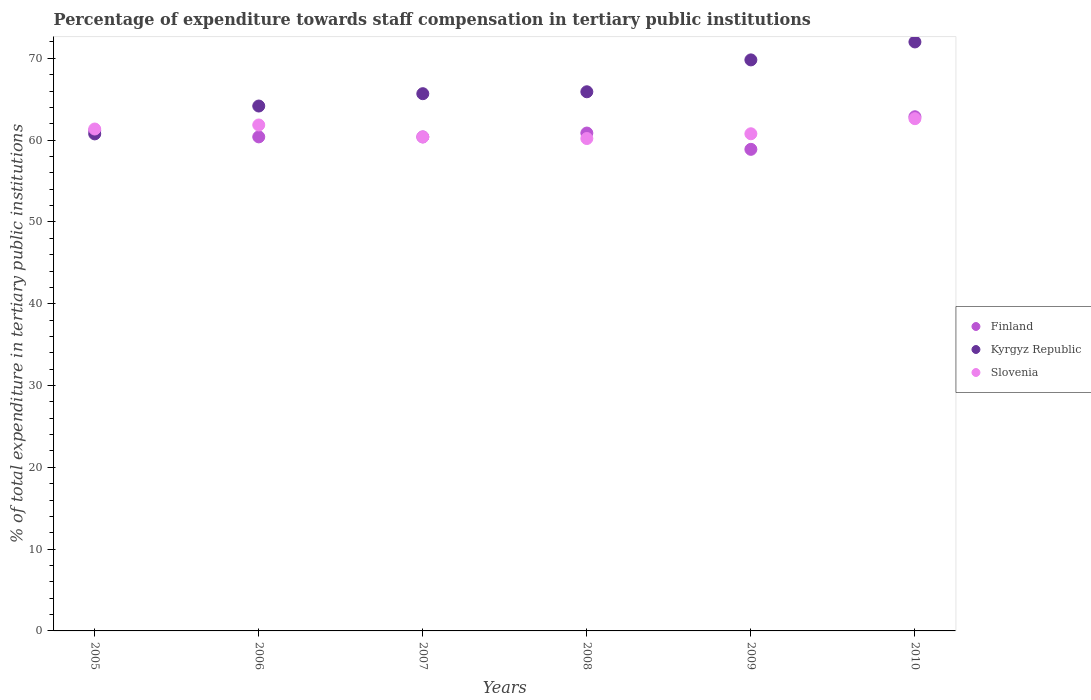What is the percentage of expenditure towards staff compensation in Finland in 2007?
Give a very brief answer. 60.39. Across all years, what is the maximum percentage of expenditure towards staff compensation in Slovenia?
Your answer should be compact. 62.63. Across all years, what is the minimum percentage of expenditure towards staff compensation in Finland?
Keep it short and to the point. 58.88. In which year was the percentage of expenditure towards staff compensation in Finland maximum?
Keep it short and to the point. 2010. In which year was the percentage of expenditure towards staff compensation in Slovenia minimum?
Your answer should be compact. 2008. What is the total percentage of expenditure towards staff compensation in Slovenia in the graph?
Provide a short and direct response. 367.21. What is the difference between the percentage of expenditure towards staff compensation in Kyrgyz Republic in 2006 and that in 2008?
Provide a succinct answer. -1.74. What is the difference between the percentage of expenditure towards staff compensation in Kyrgyz Republic in 2010 and the percentage of expenditure towards staff compensation in Slovenia in 2008?
Provide a short and direct response. 11.81. What is the average percentage of expenditure towards staff compensation in Kyrgyz Republic per year?
Offer a very short reply. 66.39. In the year 2010, what is the difference between the percentage of expenditure towards staff compensation in Kyrgyz Republic and percentage of expenditure towards staff compensation in Slovenia?
Your response must be concise. 9.38. In how many years, is the percentage of expenditure towards staff compensation in Kyrgyz Republic greater than 54 %?
Your answer should be compact. 6. What is the ratio of the percentage of expenditure towards staff compensation in Kyrgyz Republic in 2008 to that in 2009?
Make the answer very short. 0.94. What is the difference between the highest and the second highest percentage of expenditure towards staff compensation in Slovenia?
Your answer should be compact. 0.77. What is the difference between the highest and the lowest percentage of expenditure towards staff compensation in Finland?
Ensure brevity in your answer.  3.98. Is the sum of the percentage of expenditure towards staff compensation in Slovenia in 2005 and 2007 greater than the maximum percentage of expenditure towards staff compensation in Kyrgyz Republic across all years?
Provide a short and direct response. Yes. Is it the case that in every year, the sum of the percentage of expenditure towards staff compensation in Finland and percentage of expenditure towards staff compensation in Kyrgyz Republic  is greater than the percentage of expenditure towards staff compensation in Slovenia?
Provide a short and direct response. Yes. Does the percentage of expenditure towards staff compensation in Finland monotonically increase over the years?
Your answer should be compact. No. How many dotlines are there?
Offer a very short reply. 3. What is the difference between two consecutive major ticks on the Y-axis?
Keep it short and to the point. 10. Are the values on the major ticks of Y-axis written in scientific E-notation?
Keep it short and to the point. No. Does the graph contain any zero values?
Your response must be concise. No. Does the graph contain grids?
Give a very brief answer. No. How many legend labels are there?
Provide a short and direct response. 3. How are the legend labels stacked?
Offer a very short reply. Vertical. What is the title of the graph?
Offer a very short reply. Percentage of expenditure towards staff compensation in tertiary public institutions. Does "Faeroe Islands" appear as one of the legend labels in the graph?
Offer a terse response. No. What is the label or title of the Y-axis?
Keep it short and to the point. % of total expenditure in tertiary public institutions. What is the % of total expenditure in tertiary public institutions in Finland in 2005?
Provide a succinct answer. 61.15. What is the % of total expenditure in tertiary public institutions of Kyrgyz Republic in 2005?
Offer a terse response. 60.76. What is the % of total expenditure in tertiary public institutions in Slovenia in 2005?
Give a very brief answer. 61.36. What is the % of total expenditure in tertiary public institutions in Finland in 2006?
Your response must be concise. 60.4. What is the % of total expenditure in tertiary public institutions in Kyrgyz Republic in 2006?
Ensure brevity in your answer.  64.17. What is the % of total expenditure in tertiary public institutions of Slovenia in 2006?
Make the answer very short. 61.85. What is the % of total expenditure in tertiary public institutions of Finland in 2007?
Provide a succinct answer. 60.39. What is the % of total expenditure in tertiary public institutions in Kyrgyz Republic in 2007?
Provide a short and direct response. 65.68. What is the % of total expenditure in tertiary public institutions of Slovenia in 2007?
Offer a terse response. 60.39. What is the % of total expenditure in tertiary public institutions of Finland in 2008?
Your answer should be compact. 60.87. What is the % of total expenditure in tertiary public institutions in Kyrgyz Republic in 2008?
Give a very brief answer. 65.91. What is the % of total expenditure in tertiary public institutions of Slovenia in 2008?
Your answer should be compact. 60.2. What is the % of total expenditure in tertiary public institutions in Finland in 2009?
Ensure brevity in your answer.  58.88. What is the % of total expenditure in tertiary public institutions in Kyrgyz Republic in 2009?
Keep it short and to the point. 69.81. What is the % of total expenditure in tertiary public institutions of Slovenia in 2009?
Offer a very short reply. 60.78. What is the % of total expenditure in tertiary public institutions in Finland in 2010?
Offer a terse response. 62.86. What is the % of total expenditure in tertiary public institutions in Kyrgyz Republic in 2010?
Make the answer very short. 72.01. What is the % of total expenditure in tertiary public institutions in Slovenia in 2010?
Your answer should be compact. 62.63. Across all years, what is the maximum % of total expenditure in tertiary public institutions in Finland?
Your answer should be compact. 62.86. Across all years, what is the maximum % of total expenditure in tertiary public institutions in Kyrgyz Republic?
Provide a short and direct response. 72.01. Across all years, what is the maximum % of total expenditure in tertiary public institutions of Slovenia?
Provide a short and direct response. 62.63. Across all years, what is the minimum % of total expenditure in tertiary public institutions in Finland?
Offer a very short reply. 58.88. Across all years, what is the minimum % of total expenditure in tertiary public institutions in Kyrgyz Republic?
Give a very brief answer. 60.76. Across all years, what is the minimum % of total expenditure in tertiary public institutions in Slovenia?
Your answer should be very brief. 60.2. What is the total % of total expenditure in tertiary public institutions in Finland in the graph?
Your answer should be compact. 364.55. What is the total % of total expenditure in tertiary public institutions in Kyrgyz Republic in the graph?
Make the answer very short. 398.34. What is the total % of total expenditure in tertiary public institutions in Slovenia in the graph?
Provide a short and direct response. 367.21. What is the difference between the % of total expenditure in tertiary public institutions of Finland in 2005 and that in 2006?
Make the answer very short. 0.75. What is the difference between the % of total expenditure in tertiary public institutions of Kyrgyz Republic in 2005 and that in 2006?
Provide a succinct answer. -3.41. What is the difference between the % of total expenditure in tertiary public institutions of Slovenia in 2005 and that in 2006?
Provide a succinct answer. -0.49. What is the difference between the % of total expenditure in tertiary public institutions in Finland in 2005 and that in 2007?
Keep it short and to the point. 0.76. What is the difference between the % of total expenditure in tertiary public institutions in Kyrgyz Republic in 2005 and that in 2007?
Keep it short and to the point. -4.91. What is the difference between the % of total expenditure in tertiary public institutions in Slovenia in 2005 and that in 2007?
Your response must be concise. 0.97. What is the difference between the % of total expenditure in tertiary public institutions in Finland in 2005 and that in 2008?
Your answer should be compact. 0.28. What is the difference between the % of total expenditure in tertiary public institutions of Kyrgyz Republic in 2005 and that in 2008?
Provide a succinct answer. -5.15. What is the difference between the % of total expenditure in tertiary public institutions of Slovenia in 2005 and that in 2008?
Give a very brief answer. 1.16. What is the difference between the % of total expenditure in tertiary public institutions in Finland in 2005 and that in 2009?
Provide a succinct answer. 2.27. What is the difference between the % of total expenditure in tertiary public institutions of Kyrgyz Republic in 2005 and that in 2009?
Offer a very short reply. -9.05. What is the difference between the % of total expenditure in tertiary public institutions of Slovenia in 2005 and that in 2009?
Give a very brief answer. 0.58. What is the difference between the % of total expenditure in tertiary public institutions in Finland in 2005 and that in 2010?
Offer a terse response. -1.71. What is the difference between the % of total expenditure in tertiary public institutions in Kyrgyz Republic in 2005 and that in 2010?
Your answer should be very brief. -11.24. What is the difference between the % of total expenditure in tertiary public institutions in Slovenia in 2005 and that in 2010?
Offer a very short reply. -1.27. What is the difference between the % of total expenditure in tertiary public institutions of Finland in 2006 and that in 2007?
Your answer should be very brief. 0. What is the difference between the % of total expenditure in tertiary public institutions of Kyrgyz Republic in 2006 and that in 2007?
Your answer should be compact. -1.51. What is the difference between the % of total expenditure in tertiary public institutions of Slovenia in 2006 and that in 2007?
Provide a succinct answer. 1.47. What is the difference between the % of total expenditure in tertiary public institutions in Finland in 2006 and that in 2008?
Offer a very short reply. -0.47. What is the difference between the % of total expenditure in tertiary public institutions in Kyrgyz Republic in 2006 and that in 2008?
Your response must be concise. -1.74. What is the difference between the % of total expenditure in tertiary public institutions in Slovenia in 2006 and that in 2008?
Offer a terse response. 1.66. What is the difference between the % of total expenditure in tertiary public institutions in Finland in 2006 and that in 2009?
Your response must be concise. 1.52. What is the difference between the % of total expenditure in tertiary public institutions in Kyrgyz Republic in 2006 and that in 2009?
Provide a short and direct response. -5.64. What is the difference between the % of total expenditure in tertiary public institutions of Slovenia in 2006 and that in 2009?
Give a very brief answer. 1.07. What is the difference between the % of total expenditure in tertiary public institutions in Finland in 2006 and that in 2010?
Your answer should be compact. -2.46. What is the difference between the % of total expenditure in tertiary public institutions of Kyrgyz Republic in 2006 and that in 2010?
Your answer should be very brief. -7.83. What is the difference between the % of total expenditure in tertiary public institutions in Slovenia in 2006 and that in 2010?
Ensure brevity in your answer.  -0.77. What is the difference between the % of total expenditure in tertiary public institutions in Finland in 2007 and that in 2008?
Make the answer very short. -0.47. What is the difference between the % of total expenditure in tertiary public institutions in Kyrgyz Republic in 2007 and that in 2008?
Offer a terse response. -0.24. What is the difference between the % of total expenditure in tertiary public institutions of Slovenia in 2007 and that in 2008?
Your answer should be compact. 0.19. What is the difference between the % of total expenditure in tertiary public institutions in Finland in 2007 and that in 2009?
Your answer should be very brief. 1.52. What is the difference between the % of total expenditure in tertiary public institutions in Kyrgyz Republic in 2007 and that in 2009?
Your answer should be compact. -4.13. What is the difference between the % of total expenditure in tertiary public institutions in Slovenia in 2007 and that in 2009?
Your answer should be compact. -0.39. What is the difference between the % of total expenditure in tertiary public institutions of Finland in 2007 and that in 2010?
Provide a succinct answer. -2.47. What is the difference between the % of total expenditure in tertiary public institutions of Kyrgyz Republic in 2007 and that in 2010?
Provide a short and direct response. -6.33. What is the difference between the % of total expenditure in tertiary public institutions of Slovenia in 2007 and that in 2010?
Ensure brevity in your answer.  -2.24. What is the difference between the % of total expenditure in tertiary public institutions in Finland in 2008 and that in 2009?
Ensure brevity in your answer.  1.99. What is the difference between the % of total expenditure in tertiary public institutions of Kyrgyz Republic in 2008 and that in 2009?
Offer a terse response. -3.9. What is the difference between the % of total expenditure in tertiary public institutions of Slovenia in 2008 and that in 2009?
Provide a short and direct response. -0.58. What is the difference between the % of total expenditure in tertiary public institutions of Finland in 2008 and that in 2010?
Offer a terse response. -1.99. What is the difference between the % of total expenditure in tertiary public institutions of Kyrgyz Republic in 2008 and that in 2010?
Make the answer very short. -6.09. What is the difference between the % of total expenditure in tertiary public institutions in Slovenia in 2008 and that in 2010?
Offer a terse response. -2.43. What is the difference between the % of total expenditure in tertiary public institutions of Finland in 2009 and that in 2010?
Give a very brief answer. -3.98. What is the difference between the % of total expenditure in tertiary public institutions in Kyrgyz Republic in 2009 and that in 2010?
Your response must be concise. -2.19. What is the difference between the % of total expenditure in tertiary public institutions in Slovenia in 2009 and that in 2010?
Provide a short and direct response. -1.85. What is the difference between the % of total expenditure in tertiary public institutions of Finland in 2005 and the % of total expenditure in tertiary public institutions of Kyrgyz Republic in 2006?
Provide a succinct answer. -3.02. What is the difference between the % of total expenditure in tertiary public institutions of Finland in 2005 and the % of total expenditure in tertiary public institutions of Slovenia in 2006?
Your response must be concise. -0.7. What is the difference between the % of total expenditure in tertiary public institutions of Kyrgyz Republic in 2005 and the % of total expenditure in tertiary public institutions of Slovenia in 2006?
Make the answer very short. -1.09. What is the difference between the % of total expenditure in tertiary public institutions of Finland in 2005 and the % of total expenditure in tertiary public institutions of Kyrgyz Republic in 2007?
Your response must be concise. -4.53. What is the difference between the % of total expenditure in tertiary public institutions in Finland in 2005 and the % of total expenditure in tertiary public institutions in Slovenia in 2007?
Keep it short and to the point. 0.76. What is the difference between the % of total expenditure in tertiary public institutions of Kyrgyz Republic in 2005 and the % of total expenditure in tertiary public institutions of Slovenia in 2007?
Keep it short and to the point. 0.38. What is the difference between the % of total expenditure in tertiary public institutions of Finland in 2005 and the % of total expenditure in tertiary public institutions of Kyrgyz Republic in 2008?
Keep it short and to the point. -4.76. What is the difference between the % of total expenditure in tertiary public institutions of Finland in 2005 and the % of total expenditure in tertiary public institutions of Slovenia in 2008?
Your response must be concise. 0.95. What is the difference between the % of total expenditure in tertiary public institutions of Kyrgyz Republic in 2005 and the % of total expenditure in tertiary public institutions of Slovenia in 2008?
Make the answer very short. 0.57. What is the difference between the % of total expenditure in tertiary public institutions of Finland in 2005 and the % of total expenditure in tertiary public institutions of Kyrgyz Republic in 2009?
Ensure brevity in your answer.  -8.66. What is the difference between the % of total expenditure in tertiary public institutions of Finland in 2005 and the % of total expenditure in tertiary public institutions of Slovenia in 2009?
Your response must be concise. 0.37. What is the difference between the % of total expenditure in tertiary public institutions in Kyrgyz Republic in 2005 and the % of total expenditure in tertiary public institutions in Slovenia in 2009?
Give a very brief answer. -0.02. What is the difference between the % of total expenditure in tertiary public institutions of Finland in 2005 and the % of total expenditure in tertiary public institutions of Kyrgyz Republic in 2010?
Offer a very short reply. -10.86. What is the difference between the % of total expenditure in tertiary public institutions of Finland in 2005 and the % of total expenditure in tertiary public institutions of Slovenia in 2010?
Provide a succinct answer. -1.48. What is the difference between the % of total expenditure in tertiary public institutions of Kyrgyz Republic in 2005 and the % of total expenditure in tertiary public institutions of Slovenia in 2010?
Give a very brief answer. -1.86. What is the difference between the % of total expenditure in tertiary public institutions in Finland in 2006 and the % of total expenditure in tertiary public institutions in Kyrgyz Republic in 2007?
Offer a very short reply. -5.28. What is the difference between the % of total expenditure in tertiary public institutions of Finland in 2006 and the % of total expenditure in tertiary public institutions of Slovenia in 2007?
Offer a terse response. 0.01. What is the difference between the % of total expenditure in tertiary public institutions of Kyrgyz Republic in 2006 and the % of total expenditure in tertiary public institutions of Slovenia in 2007?
Offer a very short reply. 3.78. What is the difference between the % of total expenditure in tertiary public institutions of Finland in 2006 and the % of total expenditure in tertiary public institutions of Kyrgyz Republic in 2008?
Your answer should be compact. -5.51. What is the difference between the % of total expenditure in tertiary public institutions of Finland in 2006 and the % of total expenditure in tertiary public institutions of Slovenia in 2008?
Give a very brief answer. 0.2. What is the difference between the % of total expenditure in tertiary public institutions of Kyrgyz Republic in 2006 and the % of total expenditure in tertiary public institutions of Slovenia in 2008?
Make the answer very short. 3.97. What is the difference between the % of total expenditure in tertiary public institutions in Finland in 2006 and the % of total expenditure in tertiary public institutions in Kyrgyz Republic in 2009?
Offer a very short reply. -9.41. What is the difference between the % of total expenditure in tertiary public institutions in Finland in 2006 and the % of total expenditure in tertiary public institutions in Slovenia in 2009?
Offer a very short reply. -0.38. What is the difference between the % of total expenditure in tertiary public institutions in Kyrgyz Republic in 2006 and the % of total expenditure in tertiary public institutions in Slovenia in 2009?
Provide a short and direct response. 3.39. What is the difference between the % of total expenditure in tertiary public institutions in Finland in 2006 and the % of total expenditure in tertiary public institutions in Kyrgyz Republic in 2010?
Make the answer very short. -11.61. What is the difference between the % of total expenditure in tertiary public institutions of Finland in 2006 and the % of total expenditure in tertiary public institutions of Slovenia in 2010?
Give a very brief answer. -2.23. What is the difference between the % of total expenditure in tertiary public institutions in Kyrgyz Republic in 2006 and the % of total expenditure in tertiary public institutions in Slovenia in 2010?
Make the answer very short. 1.54. What is the difference between the % of total expenditure in tertiary public institutions of Finland in 2007 and the % of total expenditure in tertiary public institutions of Kyrgyz Republic in 2008?
Give a very brief answer. -5.52. What is the difference between the % of total expenditure in tertiary public institutions of Finland in 2007 and the % of total expenditure in tertiary public institutions of Slovenia in 2008?
Offer a terse response. 0.2. What is the difference between the % of total expenditure in tertiary public institutions of Kyrgyz Republic in 2007 and the % of total expenditure in tertiary public institutions of Slovenia in 2008?
Keep it short and to the point. 5.48. What is the difference between the % of total expenditure in tertiary public institutions in Finland in 2007 and the % of total expenditure in tertiary public institutions in Kyrgyz Republic in 2009?
Offer a very short reply. -9.42. What is the difference between the % of total expenditure in tertiary public institutions in Finland in 2007 and the % of total expenditure in tertiary public institutions in Slovenia in 2009?
Provide a short and direct response. -0.38. What is the difference between the % of total expenditure in tertiary public institutions of Kyrgyz Republic in 2007 and the % of total expenditure in tertiary public institutions of Slovenia in 2009?
Make the answer very short. 4.9. What is the difference between the % of total expenditure in tertiary public institutions in Finland in 2007 and the % of total expenditure in tertiary public institutions in Kyrgyz Republic in 2010?
Give a very brief answer. -11.61. What is the difference between the % of total expenditure in tertiary public institutions in Finland in 2007 and the % of total expenditure in tertiary public institutions in Slovenia in 2010?
Offer a very short reply. -2.23. What is the difference between the % of total expenditure in tertiary public institutions in Kyrgyz Republic in 2007 and the % of total expenditure in tertiary public institutions in Slovenia in 2010?
Keep it short and to the point. 3.05. What is the difference between the % of total expenditure in tertiary public institutions of Finland in 2008 and the % of total expenditure in tertiary public institutions of Kyrgyz Republic in 2009?
Give a very brief answer. -8.94. What is the difference between the % of total expenditure in tertiary public institutions in Finland in 2008 and the % of total expenditure in tertiary public institutions in Slovenia in 2009?
Make the answer very short. 0.09. What is the difference between the % of total expenditure in tertiary public institutions in Kyrgyz Republic in 2008 and the % of total expenditure in tertiary public institutions in Slovenia in 2009?
Provide a short and direct response. 5.13. What is the difference between the % of total expenditure in tertiary public institutions of Finland in 2008 and the % of total expenditure in tertiary public institutions of Kyrgyz Republic in 2010?
Offer a terse response. -11.14. What is the difference between the % of total expenditure in tertiary public institutions of Finland in 2008 and the % of total expenditure in tertiary public institutions of Slovenia in 2010?
Your answer should be very brief. -1.76. What is the difference between the % of total expenditure in tertiary public institutions in Kyrgyz Republic in 2008 and the % of total expenditure in tertiary public institutions in Slovenia in 2010?
Your answer should be compact. 3.29. What is the difference between the % of total expenditure in tertiary public institutions in Finland in 2009 and the % of total expenditure in tertiary public institutions in Kyrgyz Republic in 2010?
Ensure brevity in your answer.  -13.13. What is the difference between the % of total expenditure in tertiary public institutions in Finland in 2009 and the % of total expenditure in tertiary public institutions in Slovenia in 2010?
Make the answer very short. -3.75. What is the difference between the % of total expenditure in tertiary public institutions of Kyrgyz Republic in 2009 and the % of total expenditure in tertiary public institutions of Slovenia in 2010?
Your answer should be very brief. 7.18. What is the average % of total expenditure in tertiary public institutions of Finland per year?
Your answer should be compact. 60.76. What is the average % of total expenditure in tertiary public institutions of Kyrgyz Republic per year?
Ensure brevity in your answer.  66.39. What is the average % of total expenditure in tertiary public institutions in Slovenia per year?
Your response must be concise. 61.2. In the year 2005, what is the difference between the % of total expenditure in tertiary public institutions of Finland and % of total expenditure in tertiary public institutions of Kyrgyz Republic?
Your response must be concise. 0.39. In the year 2005, what is the difference between the % of total expenditure in tertiary public institutions in Finland and % of total expenditure in tertiary public institutions in Slovenia?
Offer a very short reply. -0.21. In the year 2005, what is the difference between the % of total expenditure in tertiary public institutions in Kyrgyz Republic and % of total expenditure in tertiary public institutions in Slovenia?
Provide a succinct answer. -0.6. In the year 2006, what is the difference between the % of total expenditure in tertiary public institutions of Finland and % of total expenditure in tertiary public institutions of Kyrgyz Republic?
Give a very brief answer. -3.77. In the year 2006, what is the difference between the % of total expenditure in tertiary public institutions in Finland and % of total expenditure in tertiary public institutions in Slovenia?
Your response must be concise. -1.45. In the year 2006, what is the difference between the % of total expenditure in tertiary public institutions in Kyrgyz Republic and % of total expenditure in tertiary public institutions in Slovenia?
Offer a terse response. 2.32. In the year 2007, what is the difference between the % of total expenditure in tertiary public institutions of Finland and % of total expenditure in tertiary public institutions of Kyrgyz Republic?
Your answer should be compact. -5.28. In the year 2007, what is the difference between the % of total expenditure in tertiary public institutions of Finland and % of total expenditure in tertiary public institutions of Slovenia?
Offer a terse response. 0.01. In the year 2007, what is the difference between the % of total expenditure in tertiary public institutions in Kyrgyz Republic and % of total expenditure in tertiary public institutions in Slovenia?
Your answer should be compact. 5.29. In the year 2008, what is the difference between the % of total expenditure in tertiary public institutions in Finland and % of total expenditure in tertiary public institutions in Kyrgyz Republic?
Keep it short and to the point. -5.05. In the year 2008, what is the difference between the % of total expenditure in tertiary public institutions of Finland and % of total expenditure in tertiary public institutions of Slovenia?
Make the answer very short. 0.67. In the year 2008, what is the difference between the % of total expenditure in tertiary public institutions of Kyrgyz Republic and % of total expenditure in tertiary public institutions of Slovenia?
Provide a succinct answer. 5.72. In the year 2009, what is the difference between the % of total expenditure in tertiary public institutions of Finland and % of total expenditure in tertiary public institutions of Kyrgyz Republic?
Provide a short and direct response. -10.93. In the year 2009, what is the difference between the % of total expenditure in tertiary public institutions of Finland and % of total expenditure in tertiary public institutions of Slovenia?
Give a very brief answer. -1.9. In the year 2009, what is the difference between the % of total expenditure in tertiary public institutions of Kyrgyz Republic and % of total expenditure in tertiary public institutions of Slovenia?
Your answer should be very brief. 9.03. In the year 2010, what is the difference between the % of total expenditure in tertiary public institutions in Finland and % of total expenditure in tertiary public institutions in Kyrgyz Republic?
Offer a terse response. -9.15. In the year 2010, what is the difference between the % of total expenditure in tertiary public institutions of Finland and % of total expenditure in tertiary public institutions of Slovenia?
Offer a terse response. 0.23. In the year 2010, what is the difference between the % of total expenditure in tertiary public institutions of Kyrgyz Republic and % of total expenditure in tertiary public institutions of Slovenia?
Your answer should be very brief. 9.38. What is the ratio of the % of total expenditure in tertiary public institutions of Finland in 2005 to that in 2006?
Your response must be concise. 1.01. What is the ratio of the % of total expenditure in tertiary public institutions of Kyrgyz Republic in 2005 to that in 2006?
Your answer should be compact. 0.95. What is the ratio of the % of total expenditure in tertiary public institutions in Slovenia in 2005 to that in 2006?
Your answer should be very brief. 0.99. What is the ratio of the % of total expenditure in tertiary public institutions of Finland in 2005 to that in 2007?
Give a very brief answer. 1.01. What is the ratio of the % of total expenditure in tertiary public institutions in Kyrgyz Republic in 2005 to that in 2007?
Your response must be concise. 0.93. What is the ratio of the % of total expenditure in tertiary public institutions in Slovenia in 2005 to that in 2007?
Provide a short and direct response. 1.02. What is the ratio of the % of total expenditure in tertiary public institutions in Kyrgyz Republic in 2005 to that in 2008?
Provide a short and direct response. 0.92. What is the ratio of the % of total expenditure in tertiary public institutions in Slovenia in 2005 to that in 2008?
Keep it short and to the point. 1.02. What is the ratio of the % of total expenditure in tertiary public institutions in Finland in 2005 to that in 2009?
Offer a very short reply. 1.04. What is the ratio of the % of total expenditure in tertiary public institutions of Kyrgyz Republic in 2005 to that in 2009?
Give a very brief answer. 0.87. What is the ratio of the % of total expenditure in tertiary public institutions of Slovenia in 2005 to that in 2009?
Provide a short and direct response. 1.01. What is the ratio of the % of total expenditure in tertiary public institutions in Finland in 2005 to that in 2010?
Keep it short and to the point. 0.97. What is the ratio of the % of total expenditure in tertiary public institutions in Kyrgyz Republic in 2005 to that in 2010?
Make the answer very short. 0.84. What is the ratio of the % of total expenditure in tertiary public institutions of Slovenia in 2005 to that in 2010?
Your answer should be very brief. 0.98. What is the ratio of the % of total expenditure in tertiary public institutions of Finland in 2006 to that in 2007?
Ensure brevity in your answer.  1. What is the ratio of the % of total expenditure in tertiary public institutions of Slovenia in 2006 to that in 2007?
Provide a short and direct response. 1.02. What is the ratio of the % of total expenditure in tertiary public institutions in Kyrgyz Republic in 2006 to that in 2008?
Your response must be concise. 0.97. What is the ratio of the % of total expenditure in tertiary public institutions of Slovenia in 2006 to that in 2008?
Offer a very short reply. 1.03. What is the ratio of the % of total expenditure in tertiary public institutions of Finland in 2006 to that in 2009?
Your answer should be very brief. 1.03. What is the ratio of the % of total expenditure in tertiary public institutions in Kyrgyz Republic in 2006 to that in 2009?
Keep it short and to the point. 0.92. What is the ratio of the % of total expenditure in tertiary public institutions of Slovenia in 2006 to that in 2009?
Keep it short and to the point. 1.02. What is the ratio of the % of total expenditure in tertiary public institutions in Finland in 2006 to that in 2010?
Ensure brevity in your answer.  0.96. What is the ratio of the % of total expenditure in tertiary public institutions of Kyrgyz Republic in 2006 to that in 2010?
Provide a succinct answer. 0.89. What is the ratio of the % of total expenditure in tertiary public institutions of Slovenia in 2007 to that in 2008?
Ensure brevity in your answer.  1. What is the ratio of the % of total expenditure in tertiary public institutions in Finland in 2007 to that in 2009?
Your response must be concise. 1.03. What is the ratio of the % of total expenditure in tertiary public institutions in Kyrgyz Republic in 2007 to that in 2009?
Your answer should be very brief. 0.94. What is the ratio of the % of total expenditure in tertiary public institutions in Slovenia in 2007 to that in 2009?
Your answer should be very brief. 0.99. What is the ratio of the % of total expenditure in tertiary public institutions of Finland in 2007 to that in 2010?
Provide a short and direct response. 0.96. What is the ratio of the % of total expenditure in tertiary public institutions of Kyrgyz Republic in 2007 to that in 2010?
Give a very brief answer. 0.91. What is the ratio of the % of total expenditure in tertiary public institutions in Slovenia in 2007 to that in 2010?
Offer a very short reply. 0.96. What is the ratio of the % of total expenditure in tertiary public institutions of Finland in 2008 to that in 2009?
Your response must be concise. 1.03. What is the ratio of the % of total expenditure in tertiary public institutions in Kyrgyz Republic in 2008 to that in 2009?
Offer a terse response. 0.94. What is the ratio of the % of total expenditure in tertiary public institutions of Slovenia in 2008 to that in 2009?
Offer a very short reply. 0.99. What is the ratio of the % of total expenditure in tertiary public institutions in Finland in 2008 to that in 2010?
Your response must be concise. 0.97. What is the ratio of the % of total expenditure in tertiary public institutions in Kyrgyz Republic in 2008 to that in 2010?
Your answer should be compact. 0.92. What is the ratio of the % of total expenditure in tertiary public institutions in Slovenia in 2008 to that in 2010?
Your answer should be compact. 0.96. What is the ratio of the % of total expenditure in tertiary public institutions in Finland in 2009 to that in 2010?
Your answer should be compact. 0.94. What is the ratio of the % of total expenditure in tertiary public institutions in Kyrgyz Republic in 2009 to that in 2010?
Keep it short and to the point. 0.97. What is the ratio of the % of total expenditure in tertiary public institutions in Slovenia in 2009 to that in 2010?
Provide a short and direct response. 0.97. What is the difference between the highest and the second highest % of total expenditure in tertiary public institutions of Finland?
Your answer should be compact. 1.71. What is the difference between the highest and the second highest % of total expenditure in tertiary public institutions of Kyrgyz Republic?
Your response must be concise. 2.19. What is the difference between the highest and the second highest % of total expenditure in tertiary public institutions of Slovenia?
Your response must be concise. 0.77. What is the difference between the highest and the lowest % of total expenditure in tertiary public institutions of Finland?
Give a very brief answer. 3.98. What is the difference between the highest and the lowest % of total expenditure in tertiary public institutions in Kyrgyz Republic?
Offer a very short reply. 11.24. What is the difference between the highest and the lowest % of total expenditure in tertiary public institutions in Slovenia?
Make the answer very short. 2.43. 